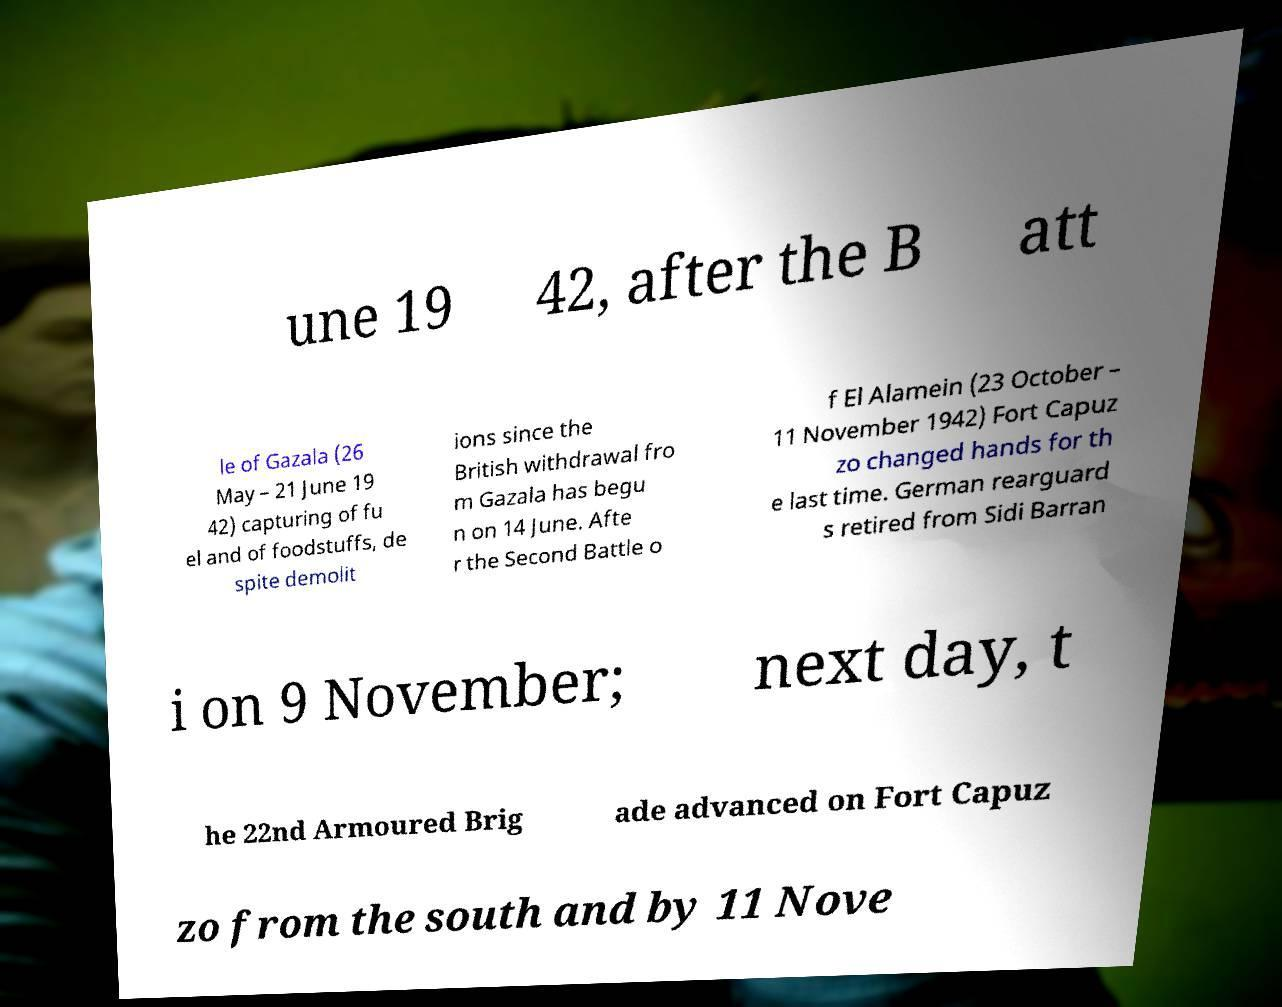Could you extract and type out the text from this image? une 19 42, after the B att le of Gazala (26 May – 21 June 19 42) capturing of fu el and of foodstuffs, de spite demolit ions since the British withdrawal fro m Gazala has begu n on 14 June. Afte r the Second Battle o f El Alamein (23 October – 11 November 1942) Fort Capuz zo changed hands for th e last time. German rearguard s retired from Sidi Barran i on 9 November; next day, t he 22nd Armoured Brig ade advanced on Fort Capuz zo from the south and by 11 Nove 